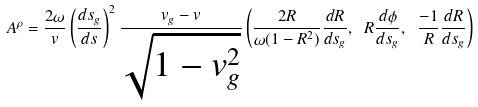Convert formula to latex. <formula><loc_0><loc_0><loc_500><loc_500>A ^ { \rho } = \frac { 2 \omega } { v } \left ( \frac { d s _ { g } } { d s } \right ) ^ { 2 } \frac { v _ { g } - v } { \sqrt { 1 - v _ { g } ^ { 2 } } } \left ( \frac { 2 R } { \omega ( 1 - R ^ { 2 } ) } \frac { d R } { d s _ { g } } , \ R \frac { d \phi } { d s _ { g } } , \ \frac { - 1 } { R } \frac { d R } { d s _ { g } } \right )</formula> 